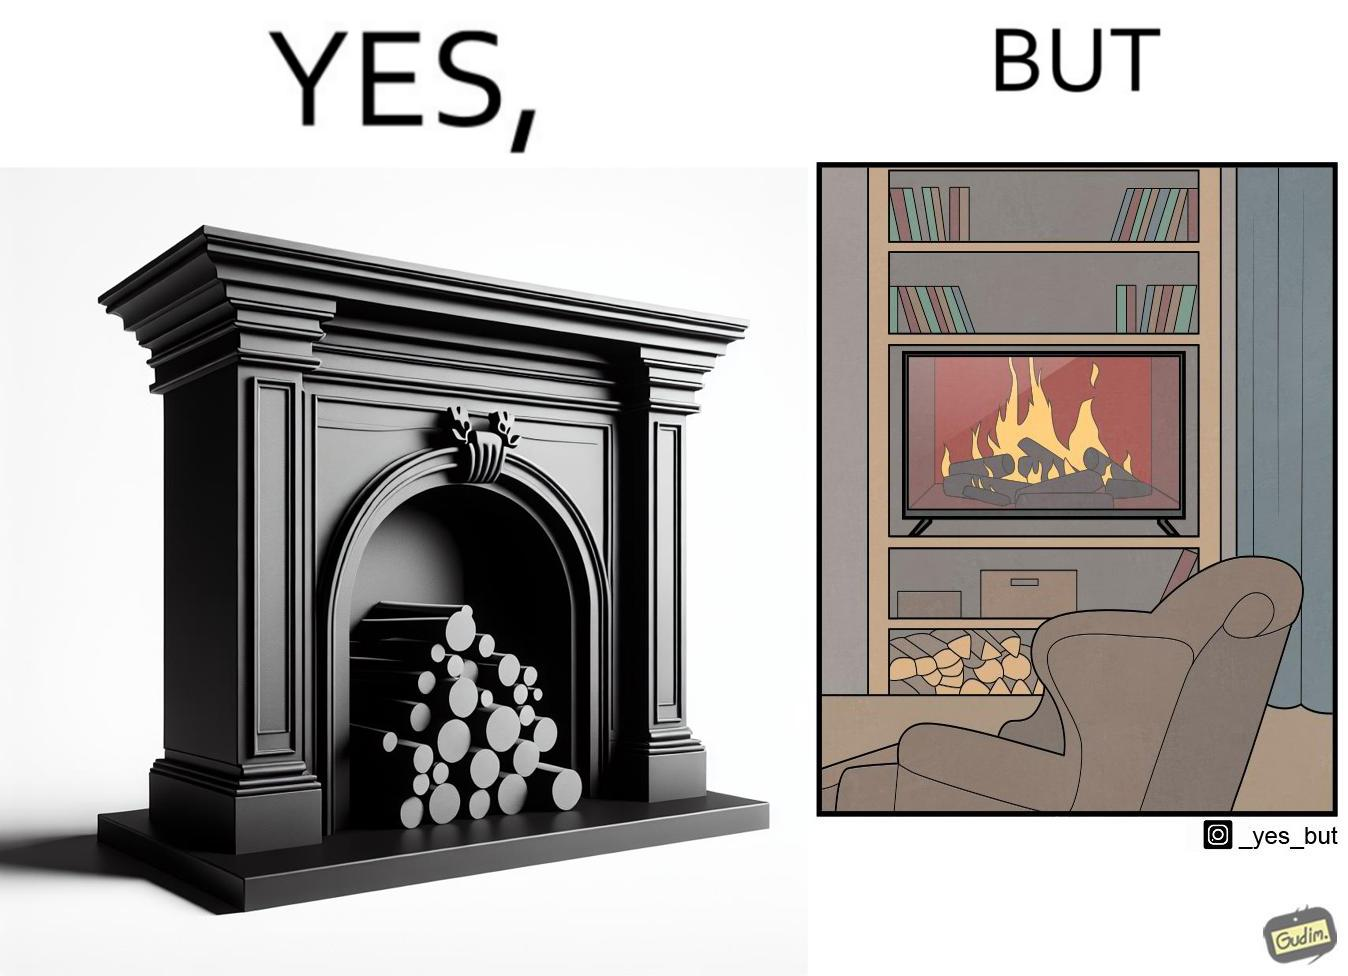Is there satirical content in this image? Yes, this image is satirical. 